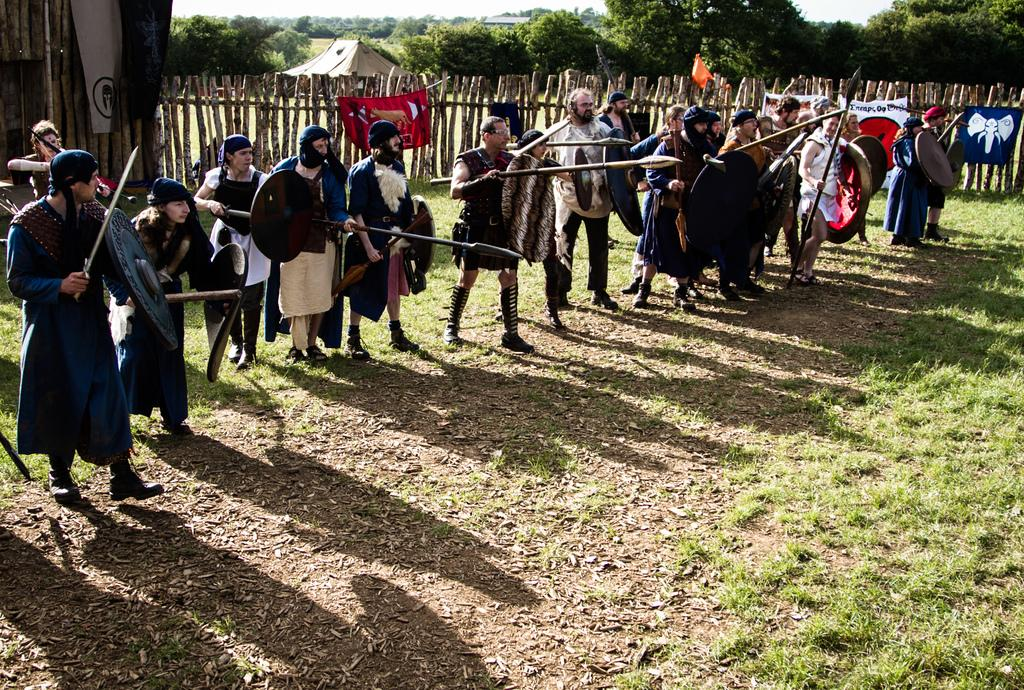How many people are present in the image? There are people in the image, but the exact number is not specified. What are the people holding in the image? The people are holding weapons in the image. What type of terrain is visible in the image? There is grass visible in the image, suggesting a grassy area. What structures or objects can be seen in the background of the image? In the background of the image, there is a fence, banners, a tent, and trees. What type of loaf is being used as a weapon in the image? There is no loaf present in the image, and no weapons resembling a loaf can be seen. What color are the lips of the person holding the weapon in the image? The image does not provide enough detail to determine the color of the person's lips. 